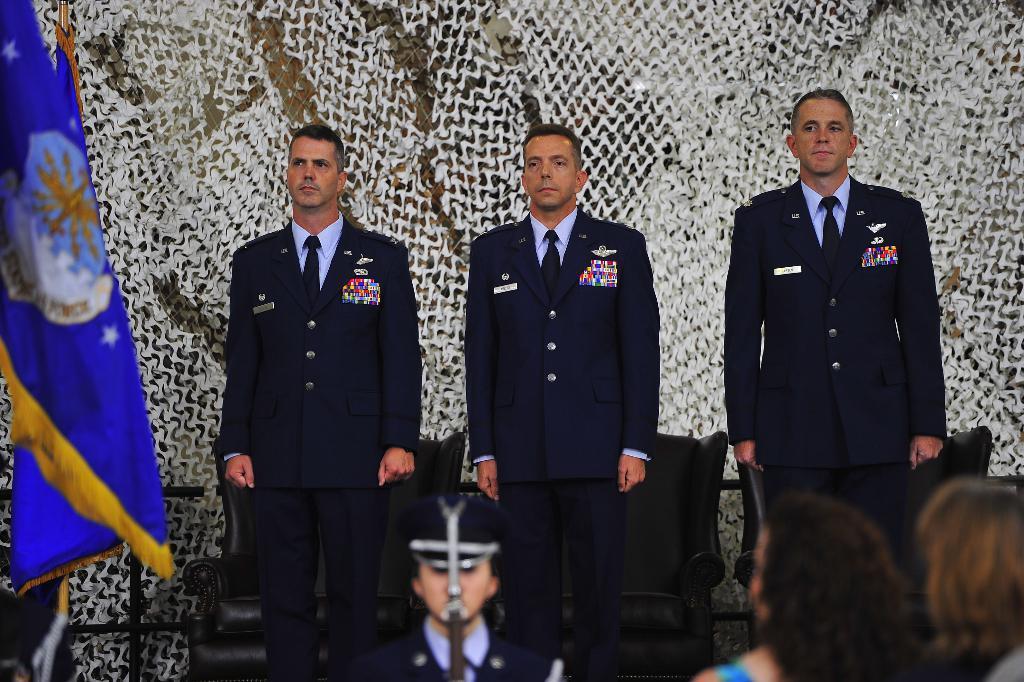In one or two sentences, can you explain what this image depicts? In this image I can see three persons standing, they are wearing blue color uniform. Background I can see a flag in blue color. 